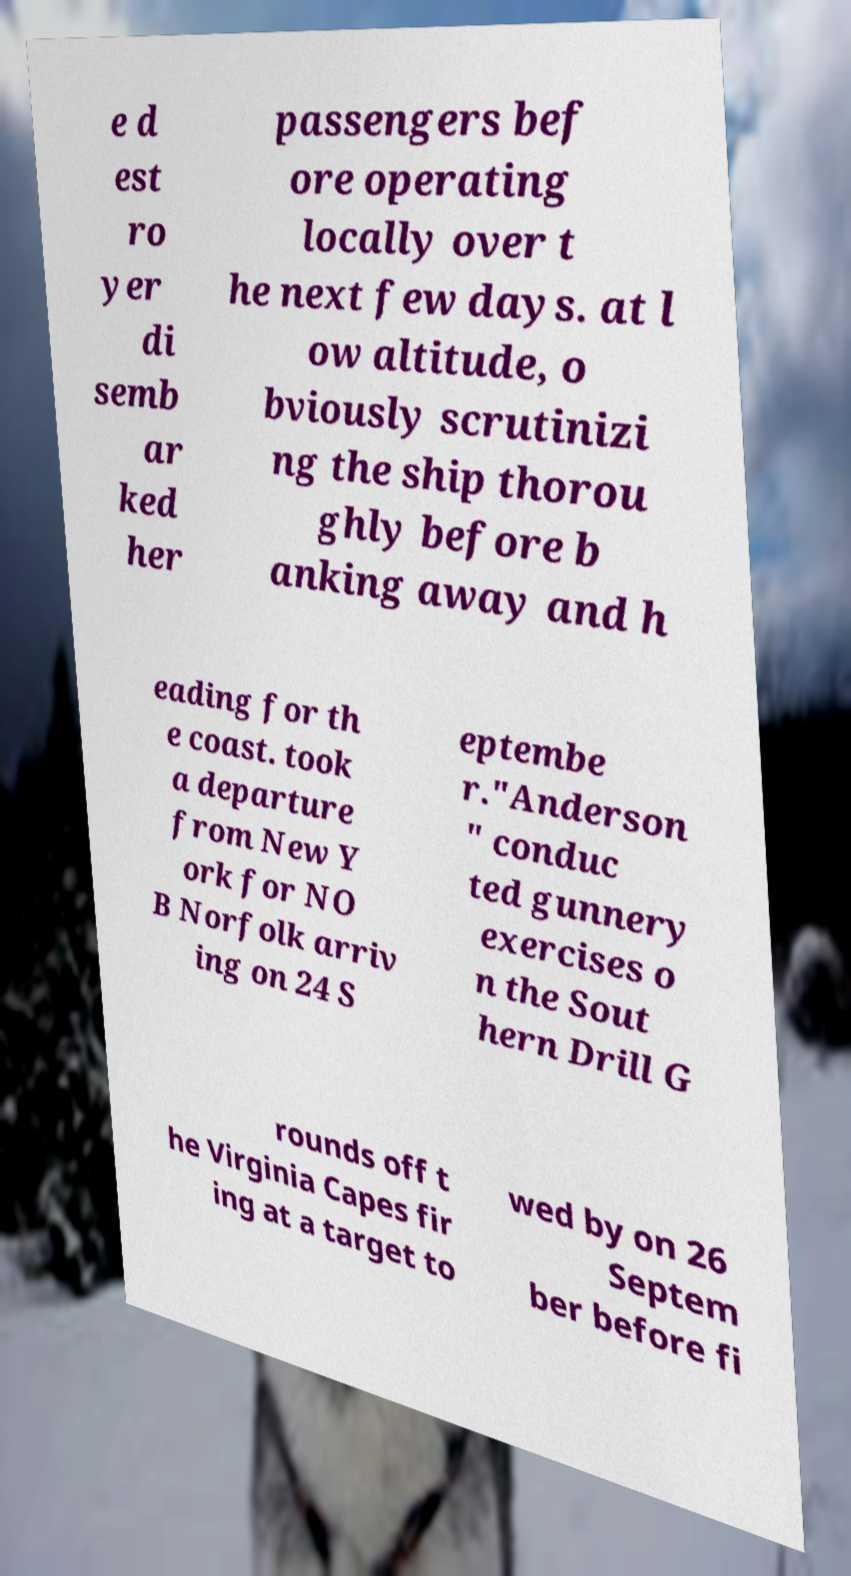What messages or text are displayed in this image? I need them in a readable, typed format. e d est ro yer di semb ar ked her passengers bef ore operating locally over t he next few days. at l ow altitude, o bviously scrutinizi ng the ship thorou ghly before b anking away and h eading for th e coast. took a departure from New Y ork for NO B Norfolk arriv ing on 24 S eptembe r."Anderson " conduc ted gunnery exercises o n the Sout hern Drill G rounds off t he Virginia Capes fir ing at a target to wed by on 26 Septem ber before fi 